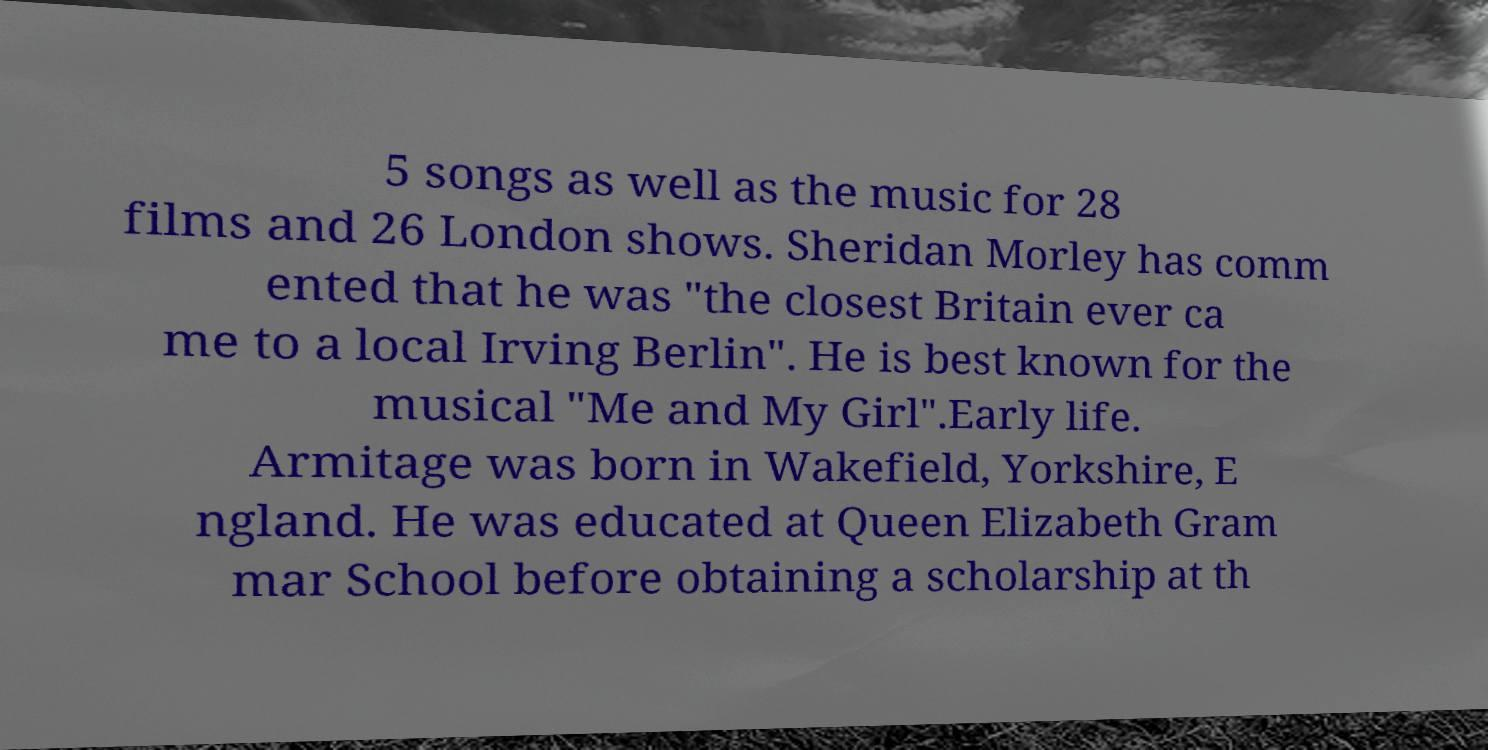Please identify and transcribe the text found in this image. 5 songs as well as the music for 28 films and 26 London shows. Sheridan Morley has comm ented that he was "the closest Britain ever ca me to a local Irving Berlin". He is best known for the musical "Me and My Girl".Early life. Armitage was born in Wakefield, Yorkshire, E ngland. He was educated at Queen Elizabeth Gram mar School before obtaining a scholarship at th 